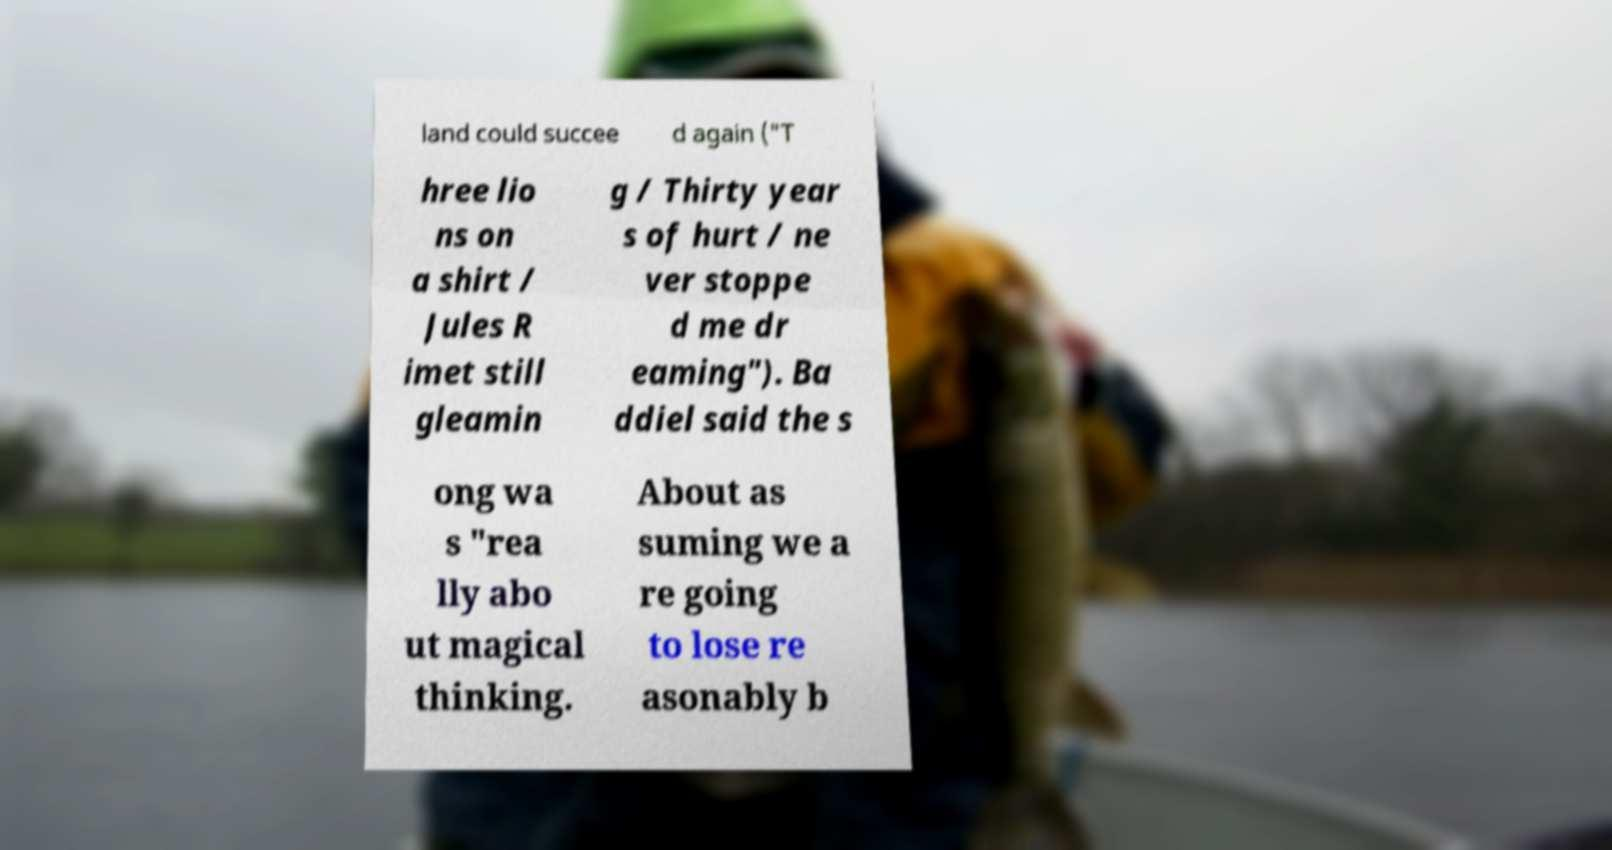Please identify and transcribe the text found in this image. land could succee d again ("T hree lio ns on a shirt / Jules R imet still gleamin g / Thirty year s of hurt / ne ver stoppe d me dr eaming"). Ba ddiel said the s ong wa s "rea lly abo ut magical thinking. About as suming we a re going to lose re asonably b 